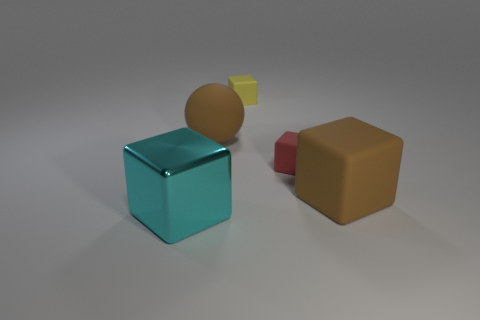Subtract all matte cubes. How many cubes are left? 1 Add 5 cyan shiny blocks. How many objects exist? 10 Subtract all brown cubes. How many cubes are left? 3 Subtract all spheres. How many objects are left? 4 Subtract all gray balls. How many green cubes are left? 0 Subtract all brown matte things. Subtract all small yellow objects. How many objects are left? 2 Add 3 yellow objects. How many yellow objects are left? 4 Add 5 brown metallic cylinders. How many brown metallic cylinders exist? 5 Subtract 0 cyan spheres. How many objects are left? 5 Subtract 1 blocks. How many blocks are left? 3 